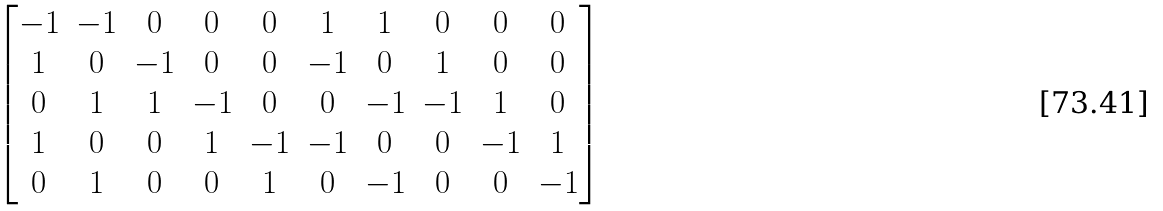Convert formula to latex. <formula><loc_0><loc_0><loc_500><loc_500>\begin{bmatrix} - 1 & - 1 & 0 & 0 & 0 & 1 & 1 & 0 & 0 & 0 \\ 1 & 0 & - 1 & 0 & 0 & - 1 & 0 & 1 & 0 & 0 \\ 0 & 1 & 1 & - 1 & 0 & 0 & - 1 & - 1 & 1 & 0 \\ 1 & 0 & 0 & 1 & - 1 & - 1 & 0 & 0 & - 1 & 1 \\ 0 & 1 & 0 & 0 & 1 & 0 & - 1 & 0 & 0 & - 1 \end{bmatrix}</formula> 